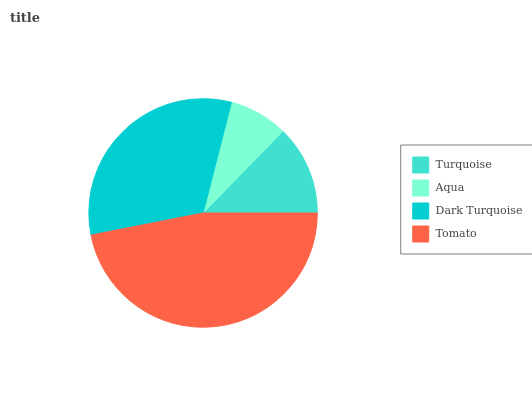Is Aqua the minimum?
Answer yes or no. Yes. Is Tomato the maximum?
Answer yes or no. Yes. Is Dark Turquoise the minimum?
Answer yes or no. No. Is Dark Turquoise the maximum?
Answer yes or no. No. Is Dark Turquoise greater than Aqua?
Answer yes or no. Yes. Is Aqua less than Dark Turquoise?
Answer yes or no. Yes. Is Aqua greater than Dark Turquoise?
Answer yes or no. No. Is Dark Turquoise less than Aqua?
Answer yes or no. No. Is Dark Turquoise the high median?
Answer yes or no. Yes. Is Turquoise the low median?
Answer yes or no. Yes. Is Turquoise the high median?
Answer yes or no. No. Is Dark Turquoise the low median?
Answer yes or no. No. 